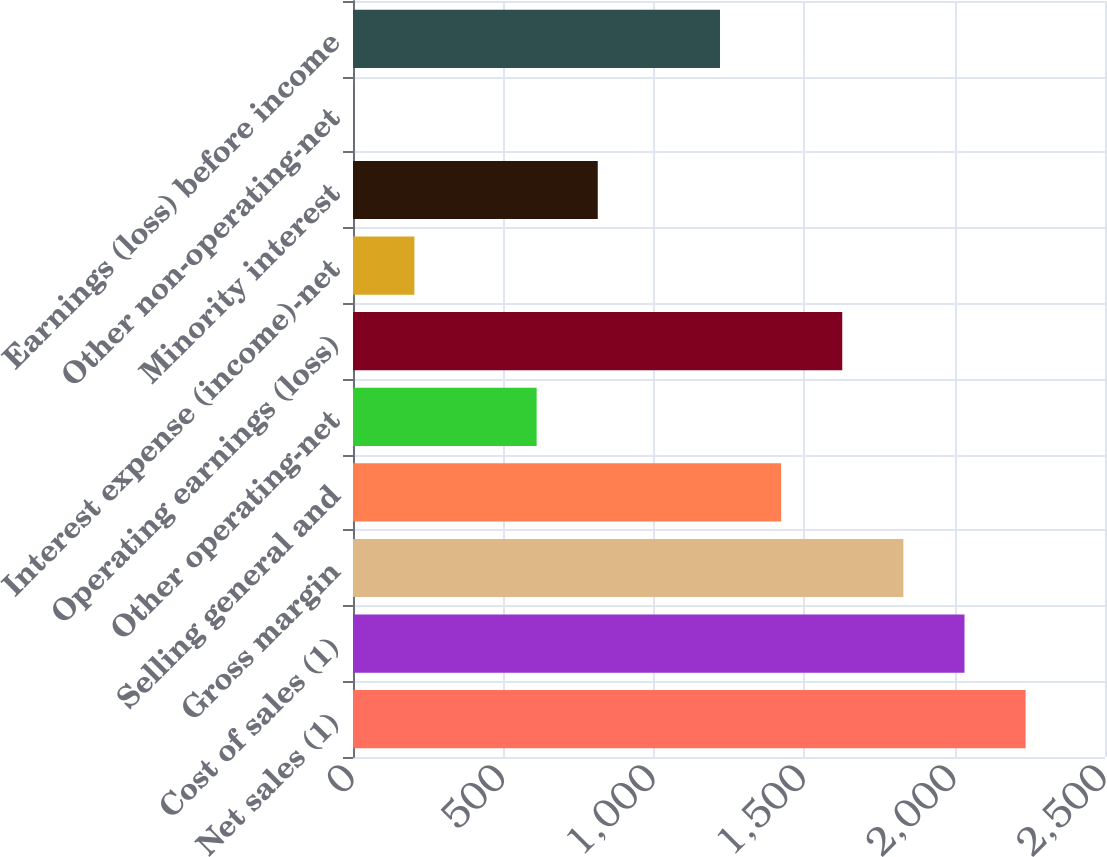Convert chart. <chart><loc_0><loc_0><loc_500><loc_500><bar_chart><fcel>Net sales (1)<fcel>Cost of sales (1)<fcel>Gross margin<fcel>Selling general and<fcel>Other operating-net<fcel>Operating earnings (loss)<fcel>Interest expense (income)-net<fcel>Minority interest<fcel>Other non-operating-net<fcel>Earnings (loss) before income<nl><fcel>2236.1<fcel>2032.9<fcel>1829.7<fcel>1423.3<fcel>610.5<fcel>1626.5<fcel>204.1<fcel>813.7<fcel>0.9<fcel>1220.1<nl></chart> 